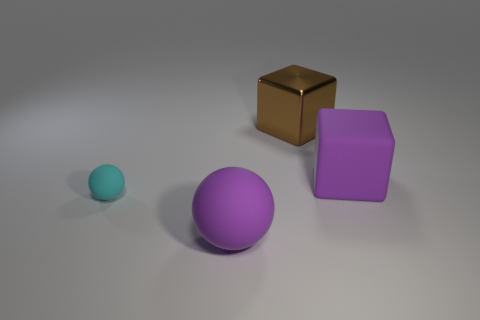Add 4 small things. How many objects exist? 8 Subtract all blue cubes. Subtract all purple cylinders. How many cubes are left? 2 Subtract all purple blocks. How many blocks are left? 1 Subtract all big rubber objects. Subtract all cyan shiny objects. How many objects are left? 2 Add 3 small matte spheres. How many small matte spheres are left? 4 Add 1 small green rubber cylinders. How many small green rubber cylinders exist? 1 Subtract 0 red spheres. How many objects are left? 4 